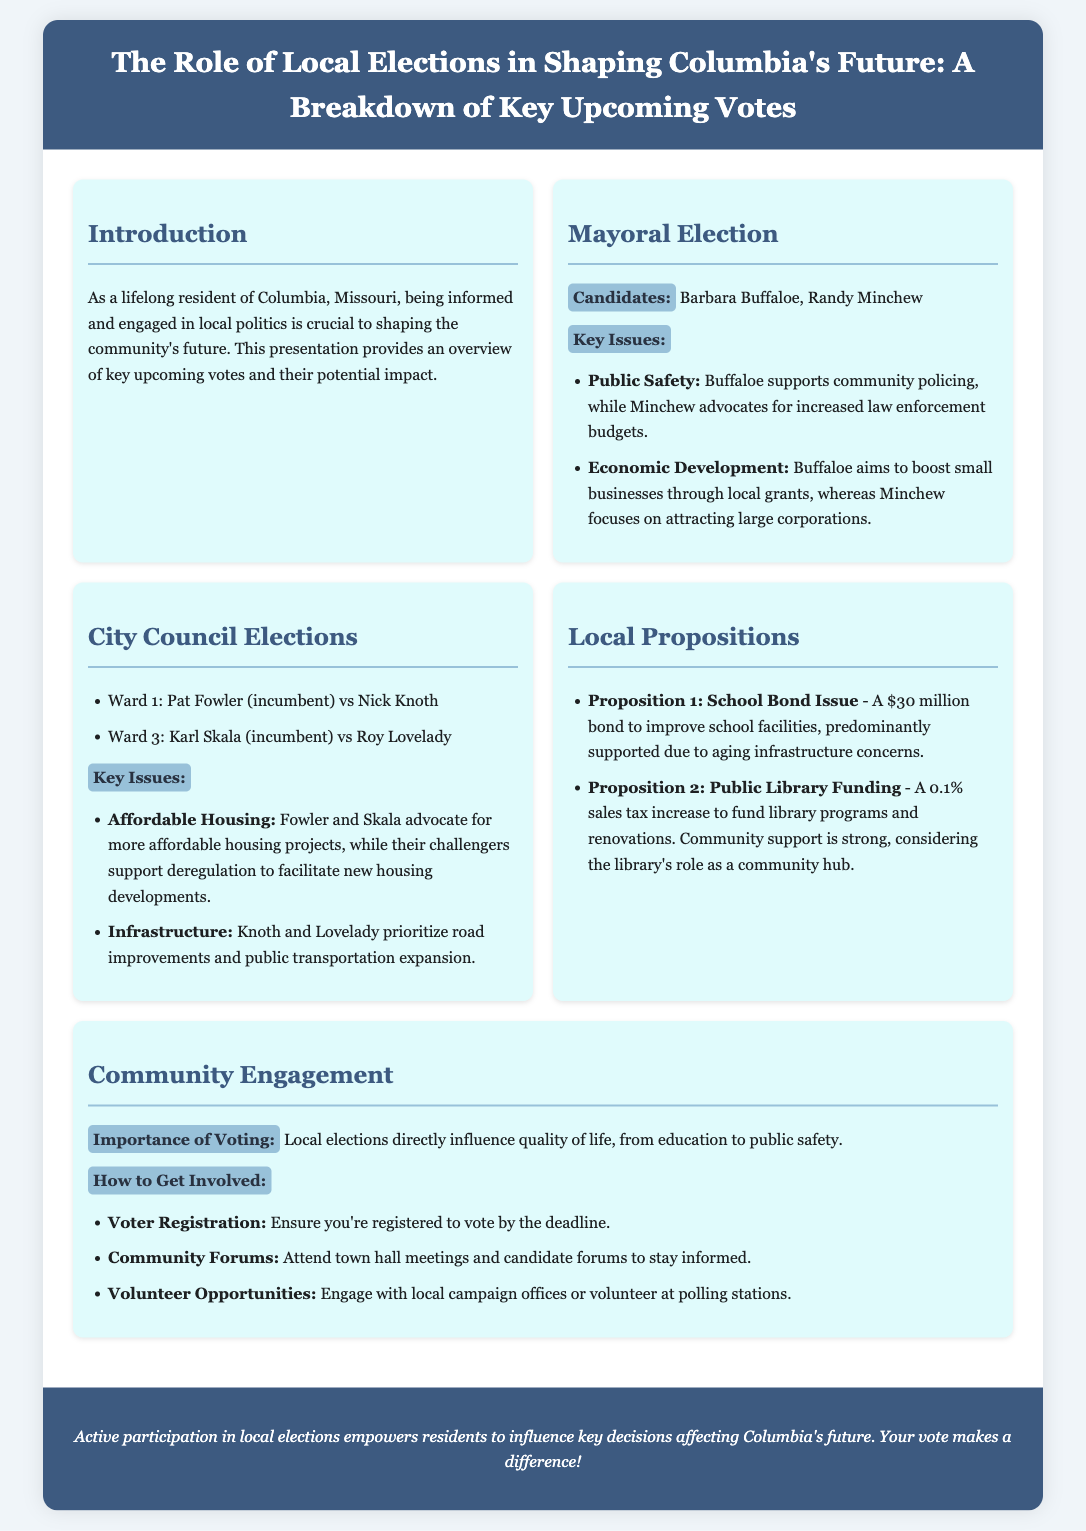What are the candidates for Mayor? The document lists two candidates for Mayor: Barbara Buffaloe and Randy Minchew.
Answer: Barbara Buffaloe, Randy Minchew What is Proposition 1 about? Proposition 1 is described as a $30 million bond issue aimed at improving school facilities.
Answer: School Bond Issue Who is the incumbent in Ward 1? The incumbent candidate for Ward 1 is Pat Fowler.
Answer: Pat Fowler What key issue do Fowler and Skala advocate for? The document states that both Fowler and Skala advocate for more affordable housing projects.
Answer: Affordable Housing What is the proposed tax increase for Public Library Funding? The document specifies a 0.1% sales tax increase for funding library programs and renovations.
Answer: 0.1% sales tax increase What is the highlight of community engagement mentioned in the document? The presentation highlights the importance of voting as it directly influences quality of life.
Answer: Importance of Voting Which candidate aims to attract large corporations? According to the document, Randy Minchew focuses on attracting large corporations.
Answer: Randy Minchew What should residents ensure before the election? The document emphasizes that residents should ensure they are registered to vote by the deadline.
Answer: Registered to vote 